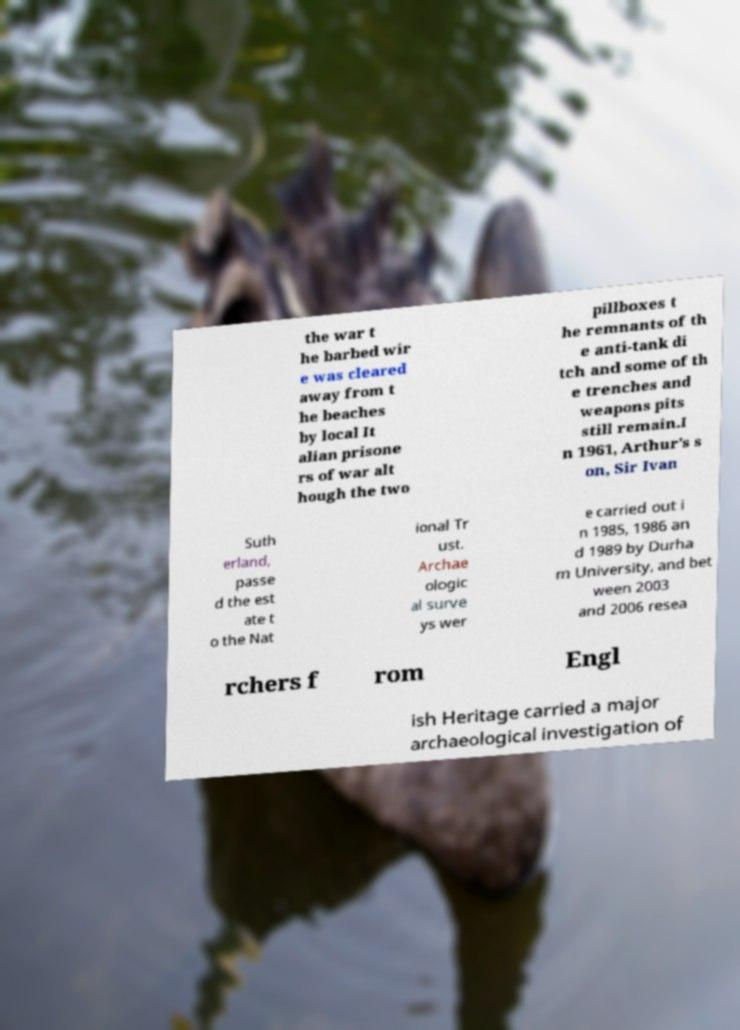Can you read and provide the text displayed in the image?This photo seems to have some interesting text. Can you extract and type it out for me? the war t he barbed wir e was cleared away from t he beaches by local It alian prisone rs of war alt hough the two pillboxes t he remnants of th e anti-tank di tch and some of th e trenches and weapons pits still remain.I n 1961, Arthur's s on, Sir Ivan Suth erland, passe d the est ate t o the Nat ional Tr ust. Archae ologic al surve ys wer e carried out i n 1985, 1986 an d 1989 by Durha m University, and bet ween 2003 and 2006 resea rchers f rom Engl ish Heritage carried a major archaeological investigation of 